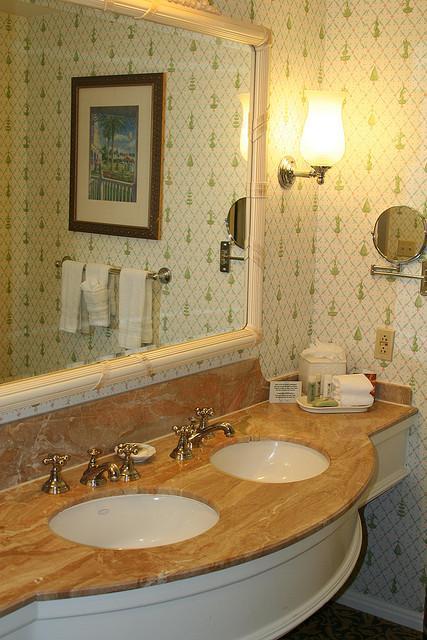How many faucets?
Give a very brief answer. 2. How many sinks can you see?
Give a very brief answer. 2. How many dogs are following the horse?
Give a very brief answer. 0. 